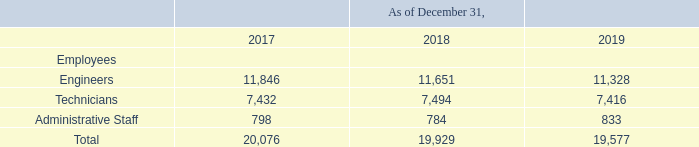As of December 31, 2019, we had 19,577 employees, which included 11,328 engineers, 7,416 technicians and 833 administrative staff performing administrative functions on a consolidated basis. We have in the past implemented, and may in the future evaluate the need to implement, labor redundancy plans based on the work performance of our employees.
Employee salaries are reviewed annually. Salaries are adjusted based on industry standards, inflation and individual performance. As an incentive, additional bonuses in cash may be paid at the discretion of management based on the performance of individuals. In addition, except under certain circumstances, R.O.C. law requires us to reserve from 10% to 15% of any offerings of our new common shares for employees’ subscription.
Our employees participate in our profit distribution pursuant to our articles of incorporation. Employees are entitled to receive additional bonuses based on a certain percentage of our allocable surplus income. On February 26, 2020, our board of directors proposed an employee bonus in cash in the aggregate amount of NT$1,133 million (US$38 million) in relation to retained earnings in 2019.
Our employees are not covered by any collective bargaining agreements. We believe we have a good relationship with our employees.
What is the criteria to adjust the salaries?  Salaries are adjusted based on industry standards, inflation and individual performance. As of December 31, 2019, how many individual were employed under various departments? As of december 31, 2019, we had 19,577 employees, which included 11,328 engineers, 7,416 technicians and 833 administrative staff performing administrative functions on a consolidated basis. What is the criteria for an employee to receive additional bonuses? Employees are entitled to receive additional bonuses based on a certain percentage of our allocable surplus income. What are the average number of Engineers employed? 
Answer scale should be: thousand. (11,846+11,651+11,328) / 3
Answer: 11608.33. What is the average number of Technicians employed?
Answer scale should be: thousand. (7,432+7,494+7,416) / 3
Answer: 7447.33. What is the average number of Administrative Staff employed? (798+784+833) / 3
Answer: 805. 